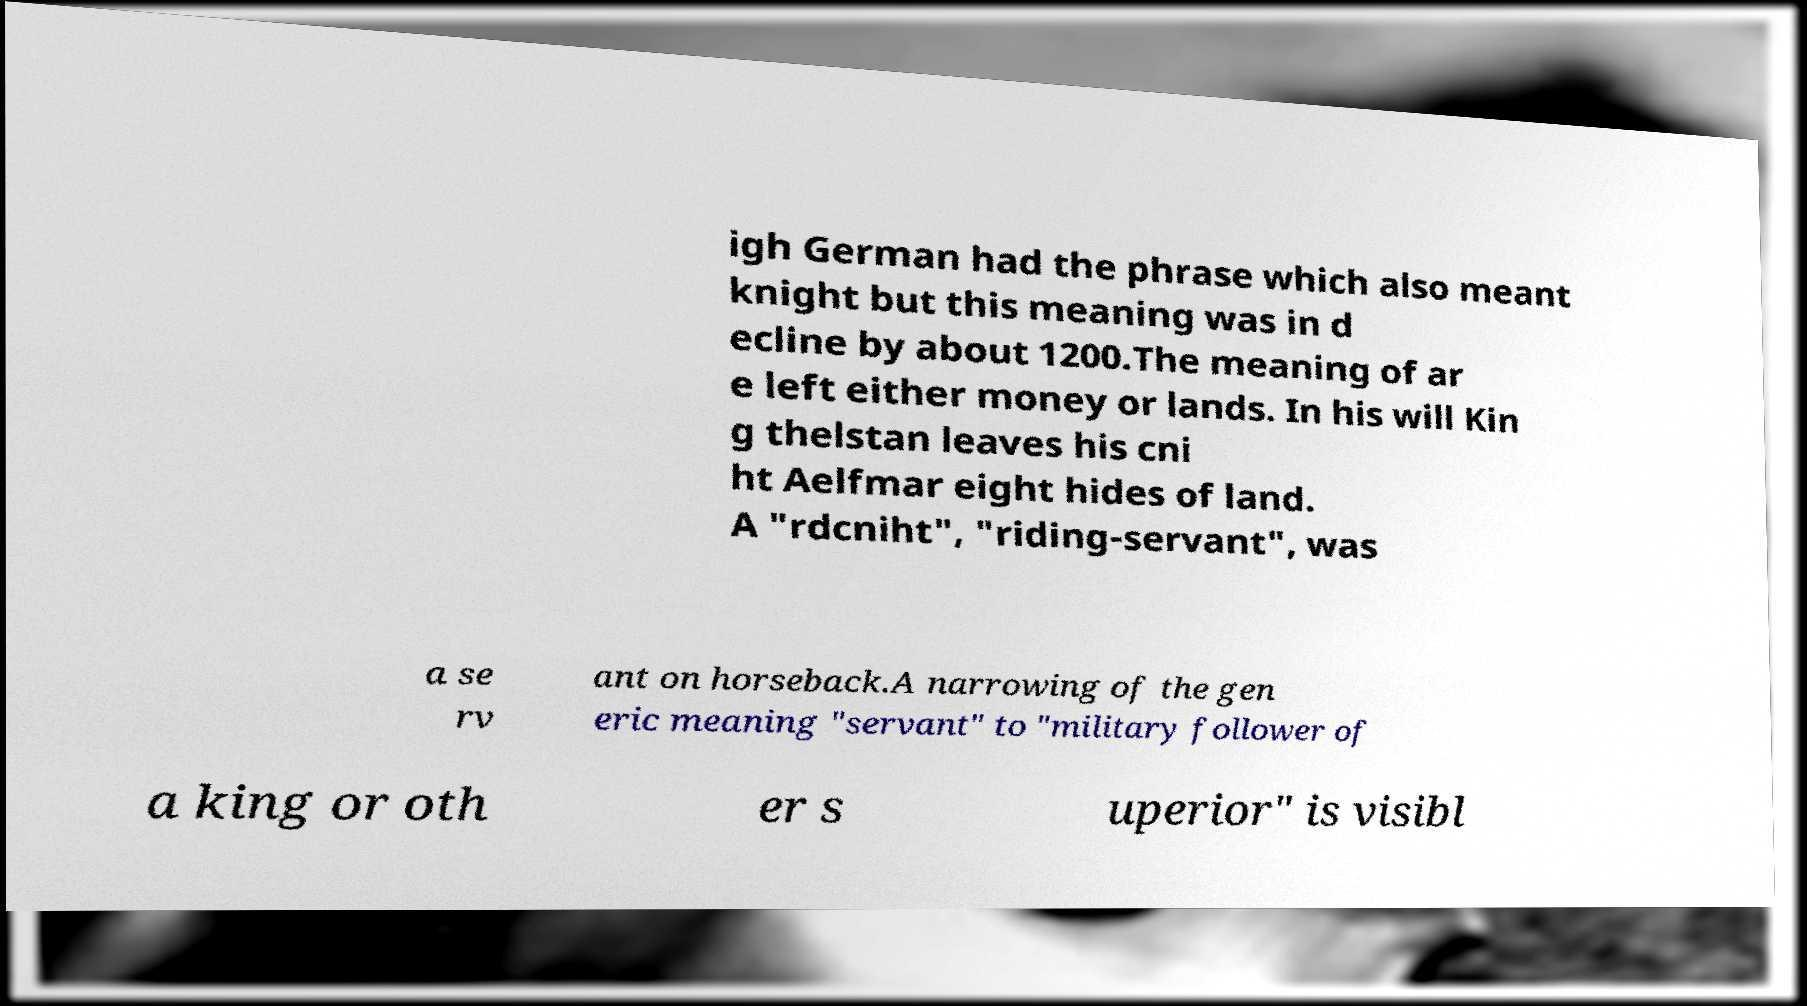Please identify and transcribe the text found in this image. igh German had the phrase which also meant knight but this meaning was in d ecline by about 1200.The meaning of ar e left either money or lands. In his will Kin g thelstan leaves his cni ht Aelfmar eight hides of land. A "rdcniht", "riding-servant", was a se rv ant on horseback.A narrowing of the gen eric meaning "servant" to "military follower of a king or oth er s uperior" is visibl 